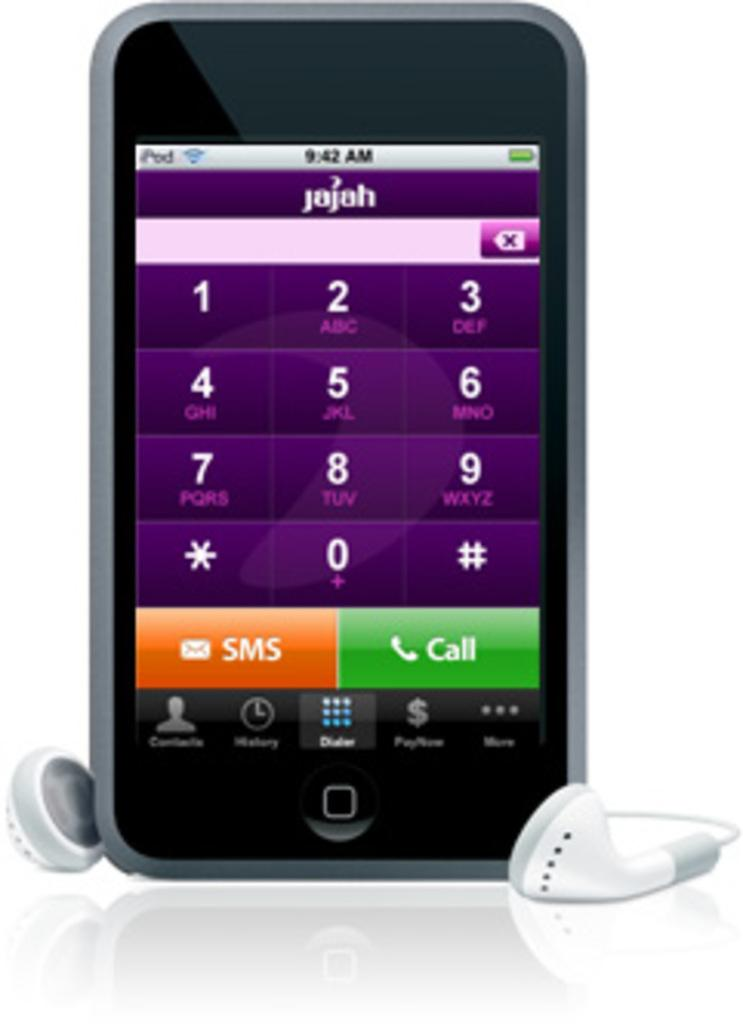<image>
Provide a brief description of the given image. A phone that says sms and call along with the numbers 0 through 9. 